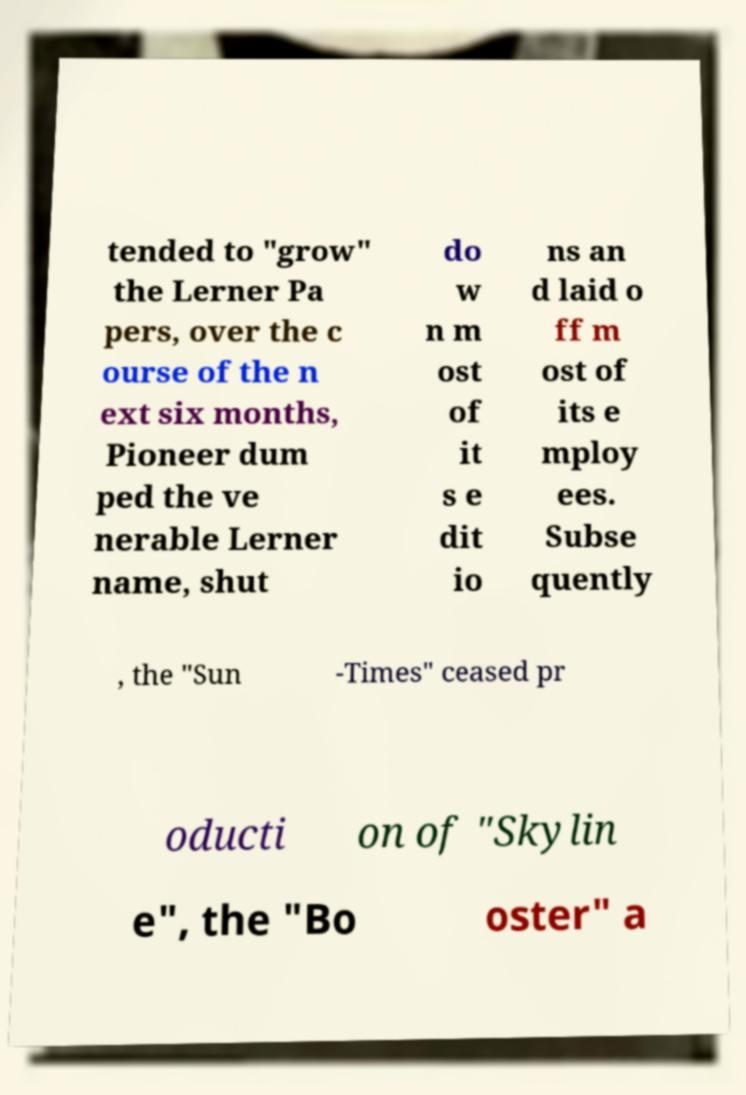Please identify and transcribe the text found in this image. tended to "grow" the Lerner Pa pers, over the c ourse of the n ext six months, Pioneer dum ped the ve nerable Lerner name, shut do w n m ost of it s e dit io ns an d laid o ff m ost of its e mploy ees. Subse quently , the "Sun -Times" ceased pr oducti on of "Skylin e", the "Bo oster" a 